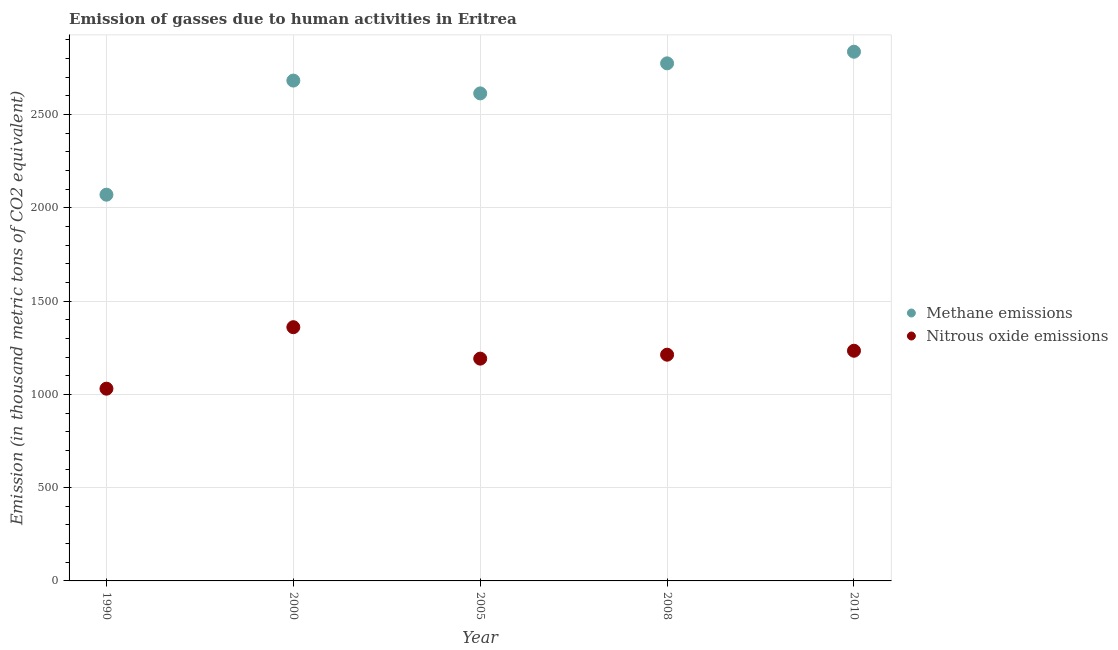How many different coloured dotlines are there?
Your answer should be very brief. 2. Is the number of dotlines equal to the number of legend labels?
Offer a terse response. Yes. What is the amount of methane emissions in 2000?
Make the answer very short. 2682.3. Across all years, what is the maximum amount of methane emissions?
Your answer should be very brief. 2837. Across all years, what is the minimum amount of methane emissions?
Keep it short and to the point. 2070.6. In which year was the amount of nitrous oxide emissions minimum?
Give a very brief answer. 1990. What is the total amount of nitrous oxide emissions in the graph?
Your answer should be compact. 6029.4. What is the difference between the amount of nitrous oxide emissions in 1990 and that in 2000?
Provide a succinct answer. -329.7. What is the difference between the amount of methane emissions in 1990 and the amount of nitrous oxide emissions in 2000?
Your answer should be compact. 710.3. What is the average amount of nitrous oxide emissions per year?
Ensure brevity in your answer.  1205.88. In the year 2008, what is the difference between the amount of methane emissions and amount of nitrous oxide emissions?
Keep it short and to the point. 1561.9. What is the ratio of the amount of nitrous oxide emissions in 2000 to that in 2005?
Offer a terse response. 1.14. Is the amount of methane emissions in 2005 less than that in 2008?
Give a very brief answer. Yes. Is the difference between the amount of methane emissions in 1990 and 2008 greater than the difference between the amount of nitrous oxide emissions in 1990 and 2008?
Provide a succinct answer. No. What is the difference between the highest and the second highest amount of methane emissions?
Your answer should be very brief. 62.3. What is the difference between the highest and the lowest amount of nitrous oxide emissions?
Keep it short and to the point. 329.7. In how many years, is the amount of nitrous oxide emissions greater than the average amount of nitrous oxide emissions taken over all years?
Your answer should be compact. 3. Is the sum of the amount of nitrous oxide emissions in 2000 and 2008 greater than the maximum amount of methane emissions across all years?
Provide a short and direct response. No. Does the amount of nitrous oxide emissions monotonically increase over the years?
Provide a short and direct response. No. How many dotlines are there?
Keep it short and to the point. 2. How many years are there in the graph?
Your answer should be compact. 5. Are the values on the major ticks of Y-axis written in scientific E-notation?
Make the answer very short. No. Does the graph contain grids?
Make the answer very short. Yes. How many legend labels are there?
Provide a short and direct response. 2. What is the title of the graph?
Offer a terse response. Emission of gasses due to human activities in Eritrea. Does "Nitrous oxide emissions" appear as one of the legend labels in the graph?
Make the answer very short. Yes. What is the label or title of the X-axis?
Keep it short and to the point. Year. What is the label or title of the Y-axis?
Offer a very short reply. Emission (in thousand metric tons of CO2 equivalent). What is the Emission (in thousand metric tons of CO2 equivalent) in Methane emissions in 1990?
Offer a terse response. 2070.6. What is the Emission (in thousand metric tons of CO2 equivalent) of Nitrous oxide emissions in 1990?
Your answer should be very brief. 1030.6. What is the Emission (in thousand metric tons of CO2 equivalent) of Methane emissions in 2000?
Your answer should be compact. 2682.3. What is the Emission (in thousand metric tons of CO2 equivalent) of Nitrous oxide emissions in 2000?
Ensure brevity in your answer.  1360.3. What is the Emission (in thousand metric tons of CO2 equivalent) of Methane emissions in 2005?
Provide a succinct answer. 2613.6. What is the Emission (in thousand metric tons of CO2 equivalent) in Nitrous oxide emissions in 2005?
Your answer should be very brief. 1191.7. What is the Emission (in thousand metric tons of CO2 equivalent) in Methane emissions in 2008?
Provide a short and direct response. 2774.7. What is the Emission (in thousand metric tons of CO2 equivalent) of Nitrous oxide emissions in 2008?
Provide a succinct answer. 1212.8. What is the Emission (in thousand metric tons of CO2 equivalent) in Methane emissions in 2010?
Your response must be concise. 2837. What is the Emission (in thousand metric tons of CO2 equivalent) of Nitrous oxide emissions in 2010?
Provide a succinct answer. 1234. Across all years, what is the maximum Emission (in thousand metric tons of CO2 equivalent) of Methane emissions?
Provide a succinct answer. 2837. Across all years, what is the maximum Emission (in thousand metric tons of CO2 equivalent) in Nitrous oxide emissions?
Ensure brevity in your answer.  1360.3. Across all years, what is the minimum Emission (in thousand metric tons of CO2 equivalent) in Methane emissions?
Your response must be concise. 2070.6. Across all years, what is the minimum Emission (in thousand metric tons of CO2 equivalent) of Nitrous oxide emissions?
Your answer should be compact. 1030.6. What is the total Emission (in thousand metric tons of CO2 equivalent) of Methane emissions in the graph?
Your response must be concise. 1.30e+04. What is the total Emission (in thousand metric tons of CO2 equivalent) of Nitrous oxide emissions in the graph?
Your response must be concise. 6029.4. What is the difference between the Emission (in thousand metric tons of CO2 equivalent) in Methane emissions in 1990 and that in 2000?
Give a very brief answer. -611.7. What is the difference between the Emission (in thousand metric tons of CO2 equivalent) of Nitrous oxide emissions in 1990 and that in 2000?
Give a very brief answer. -329.7. What is the difference between the Emission (in thousand metric tons of CO2 equivalent) in Methane emissions in 1990 and that in 2005?
Provide a succinct answer. -543. What is the difference between the Emission (in thousand metric tons of CO2 equivalent) of Nitrous oxide emissions in 1990 and that in 2005?
Your response must be concise. -161.1. What is the difference between the Emission (in thousand metric tons of CO2 equivalent) in Methane emissions in 1990 and that in 2008?
Your answer should be very brief. -704.1. What is the difference between the Emission (in thousand metric tons of CO2 equivalent) in Nitrous oxide emissions in 1990 and that in 2008?
Make the answer very short. -182.2. What is the difference between the Emission (in thousand metric tons of CO2 equivalent) of Methane emissions in 1990 and that in 2010?
Provide a succinct answer. -766.4. What is the difference between the Emission (in thousand metric tons of CO2 equivalent) in Nitrous oxide emissions in 1990 and that in 2010?
Offer a terse response. -203.4. What is the difference between the Emission (in thousand metric tons of CO2 equivalent) of Methane emissions in 2000 and that in 2005?
Ensure brevity in your answer.  68.7. What is the difference between the Emission (in thousand metric tons of CO2 equivalent) of Nitrous oxide emissions in 2000 and that in 2005?
Ensure brevity in your answer.  168.6. What is the difference between the Emission (in thousand metric tons of CO2 equivalent) in Methane emissions in 2000 and that in 2008?
Keep it short and to the point. -92.4. What is the difference between the Emission (in thousand metric tons of CO2 equivalent) in Nitrous oxide emissions in 2000 and that in 2008?
Provide a short and direct response. 147.5. What is the difference between the Emission (in thousand metric tons of CO2 equivalent) in Methane emissions in 2000 and that in 2010?
Give a very brief answer. -154.7. What is the difference between the Emission (in thousand metric tons of CO2 equivalent) of Nitrous oxide emissions in 2000 and that in 2010?
Keep it short and to the point. 126.3. What is the difference between the Emission (in thousand metric tons of CO2 equivalent) in Methane emissions in 2005 and that in 2008?
Your answer should be very brief. -161.1. What is the difference between the Emission (in thousand metric tons of CO2 equivalent) in Nitrous oxide emissions in 2005 and that in 2008?
Offer a very short reply. -21.1. What is the difference between the Emission (in thousand metric tons of CO2 equivalent) in Methane emissions in 2005 and that in 2010?
Offer a terse response. -223.4. What is the difference between the Emission (in thousand metric tons of CO2 equivalent) in Nitrous oxide emissions in 2005 and that in 2010?
Give a very brief answer. -42.3. What is the difference between the Emission (in thousand metric tons of CO2 equivalent) of Methane emissions in 2008 and that in 2010?
Offer a very short reply. -62.3. What is the difference between the Emission (in thousand metric tons of CO2 equivalent) in Nitrous oxide emissions in 2008 and that in 2010?
Your response must be concise. -21.2. What is the difference between the Emission (in thousand metric tons of CO2 equivalent) of Methane emissions in 1990 and the Emission (in thousand metric tons of CO2 equivalent) of Nitrous oxide emissions in 2000?
Give a very brief answer. 710.3. What is the difference between the Emission (in thousand metric tons of CO2 equivalent) of Methane emissions in 1990 and the Emission (in thousand metric tons of CO2 equivalent) of Nitrous oxide emissions in 2005?
Your answer should be compact. 878.9. What is the difference between the Emission (in thousand metric tons of CO2 equivalent) in Methane emissions in 1990 and the Emission (in thousand metric tons of CO2 equivalent) in Nitrous oxide emissions in 2008?
Keep it short and to the point. 857.8. What is the difference between the Emission (in thousand metric tons of CO2 equivalent) in Methane emissions in 1990 and the Emission (in thousand metric tons of CO2 equivalent) in Nitrous oxide emissions in 2010?
Make the answer very short. 836.6. What is the difference between the Emission (in thousand metric tons of CO2 equivalent) of Methane emissions in 2000 and the Emission (in thousand metric tons of CO2 equivalent) of Nitrous oxide emissions in 2005?
Make the answer very short. 1490.6. What is the difference between the Emission (in thousand metric tons of CO2 equivalent) in Methane emissions in 2000 and the Emission (in thousand metric tons of CO2 equivalent) in Nitrous oxide emissions in 2008?
Ensure brevity in your answer.  1469.5. What is the difference between the Emission (in thousand metric tons of CO2 equivalent) of Methane emissions in 2000 and the Emission (in thousand metric tons of CO2 equivalent) of Nitrous oxide emissions in 2010?
Provide a short and direct response. 1448.3. What is the difference between the Emission (in thousand metric tons of CO2 equivalent) in Methane emissions in 2005 and the Emission (in thousand metric tons of CO2 equivalent) in Nitrous oxide emissions in 2008?
Keep it short and to the point. 1400.8. What is the difference between the Emission (in thousand metric tons of CO2 equivalent) of Methane emissions in 2005 and the Emission (in thousand metric tons of CO2 equivalent) of Nitrous oxide emissions in 2010?
Make the answer very short. 1379.6. What is the difference between the Emission (in thousand metric tons of CO2 equivalent) of Methane emissions in 2008 and the Emission (in thousand metric tons of CO2 equivalent) of Nitrous oxide emissions in 2010?
Provide a succinct answer. 1540.7. What is the average Emission (in thousand metric tons of CO2 equivalent) of Methane emissions per year?
Offer a terse response. 2595.64. What is the average Emission (in thousand metric tons of CO2 equivalent) in Nitrous oxide emissions per year?
Give a very brief answer. 1205.88. In the year 1990, what is the difference between the Emission (in thousand metric tons of CO2 equivalent) in Methane emissions and Emission (in thousand metric tons of CO2 equivalent) in Nitrous oxide emissions?
Offer a terse response. 1040. In the year 2000, what is the difference between the Emission (in thousand metric tons of CO2 equivalent) of Methane emissions and Emission (in thousand metric tons of CO2 equivalent) of Nitrous oxide emissions?
Give a very brief answer. 1322. In the year 2005, what is the difference between the Emission (in thousand metric tons of CO2 equivalent) of Methane emissions and Emission (in thousand metric tons of CO2 equivalent) of Nitrous oxide emissions?
Offer a terse response. 1421.9. In the year 2008, what is the difference between the Emission (in thousand metric tons of CO2 equivalent) in Methane emissions and Emission (in thousand metric tons of CO2 equivalent) in Nitrous oxide emissions?
Give a very brief answer. 1561.9. In the year 2010, what is the difference between the Emission (in thousand metric tons of CO2 equivalent) in Methane emissions and Emission (in thousand metric tons of CO2 equivalent) in Nitrous oxide emissions?
Give a very brief answer. 1603. What is the ratio of the Emission (in thousand metric tons of CO2 equivalent) in Methane emissions in 1990 to that in 2000?
Your response must be concise. 0.77. What is the ratio of the Emission (in thousand metric tons of CO2 equivalent) of Nitrous oxide emissions in 1990 to that in 2000?
Your answer should be compact. 0.76. What is the ratio of the Emission (in thousand metric tons of CO2 equivalent) in Methane emissions in 1990 to that in 2005?
Provide a succinct answer. 0.79. What is the ratio of the Emission (in thousand metric tons of CO2 equivalent) of Nitrous oxide emissions in 1990 to that in 2005?
Make the answer very short. 0.86. What is the ratio of the Emission (in thousand metric tons of CO2 equivalent) of Methane emissions in 1990 to that in 2008?
Your answer should be compact. 0.75. What is the ratio of the Emission (in thousand metric tons of CO2 equivalent) of Nitrous oxide emissions in 1990 to that in 2008?
Keep it short and to the point. 0.85. What is the ratio of the Emission (in thousand metric tons of CO2 equivalent) in Methane emissions in 1990 to that in 2010?
Give a very brief answer. 0.73. What is the ratio of the Emission (in thousand metric tons of CO2 equivalent) of Nitrous oxide emissions in 1990 to that in 2010?
Provide a succinct answer. 0.84. What is the ratio of the Emission (in thousand metric tons of CO2 equivalent) of Methane emissions in 2000 to that in 2005?
Offer a very short reply. 1.03. What is the ratio of the Emission (in thousand metric tons of CO2 equivalent) of Nitrous oxide emissions in 2000 to that in 2005?
Offer a very short reply. 1.14. What is the ratio of the Emission (in thousand metric tons of CO2 equivalent) of Methane emissions in 2000 to that in 2008?
Make the answer very short. 0.97. What is the ratio of the Emission (in thousand metric tons of CO2 equivalent) of Nitrous oxide emissions in 2000 to that in 2008?
Make the answer very short. 1.12. What is the ratio of the Emission (in thousand metric tons of CO2 equivalent) in Methane emissions in 2000 to that in 2010?
Your answer should be very brief. 0.95. What is the ratio of the Emission (in thousand metric tons of CO2 equivalent) of Nitrous oxide emissions in 2000 to that in 2010?
Offer a very short reply. 1.1. What is the ratio of the Emission (in thousand metric tons of CO2 equivalent) of Methane emissions in 2005 to that in 2008?
Ensure brevity in your answer.  0.94. What is the ratio of the Emission (in thousand metric tons of CO2 equivalent) in Nitrous oxide emissions in 2005 to that in 2008?
Ensure brevity in your answer.  0.98. What is the ratio of the Emission (in thousand metric tons of CO2 equivalent) in Methane emissions in 2005 to that in 2010?
Provide a short and direct response. 0.92. What is the ratio of the Emission (in thousand metric tons of CO2 equivalent) in Nitrous oxide emissions in 2005 to that in 2010?
Provide a short and direct response. 0.97. What is the ratio of the Emission (in thousand metric tons of CO2 equivalent) in Nitrous oxide emissions in 2008 to that in 2010?
Your answer should be very brief. 0.98. What is the difference between the highest and the second highest Emission (in thousand metric tons of CO2 equivalent) in Methane emissions?
Your response must be concise. 62.3. What is the difference between the highest and the second highest Emission (in thousand metric tons of CO2 equivalent) of Nitrous oxide emissions?
Ensure brevity in your answer.  126.3. What is the difference between the highest and the lowest Emission (in thousand metric tons of CO2 equivalent) in Methane emissions?
Provide a short and direct response. 766.4. What is the difference between the highest and the lowest Emission (in thousand metric tons of CO2 equivalent) in Nitrous oxide emissions?
Ensure brevity in your answer.  329.7. 